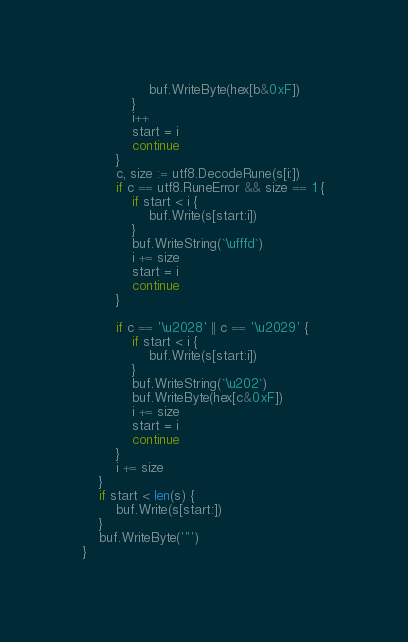<code> <loc_0><loc_0><loc_500><loc_500><_Go_>				buf.WriteByte(hex[b&0xF])
			}
			i++
			start = i
			continue
		}
		c, size := utf8.DecodeRune(s[i:])
		if c == utf8.RuneError && size == 1 {
			if start < i {
				buf.Write(s[start:i])
			}
			buf.WriteString(`\ufffd`)
			i += size
			start = i
			continue
		}

		if c == '\u2028' || c == '\u2029' {
			if start < i {
				buf.Write(s[start:i])
			}
			buf.WriteString(`\u202`)
			buf.WriteByte(hex[c&0xF])
			i += size
			start = i
			continue
		}
		i += size
	}
	if start < len(s) {
		buf.Write(s[start:])
	}
	buf.WriteByte('"')
}
</code> 